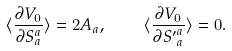<formula> <loc_0><loc_0><loc_500><loc_500>\langle \frac { \partial V _ { 0 } } { \partial S _ { a } ^ { a } } \rangle = 2 A _ { a } , \quad \langle \frac { \partial V _ { 0 } } { \partial { S ^ { \prime } } _ { a } ^ { a } } \rangle = 0 .</formula> 